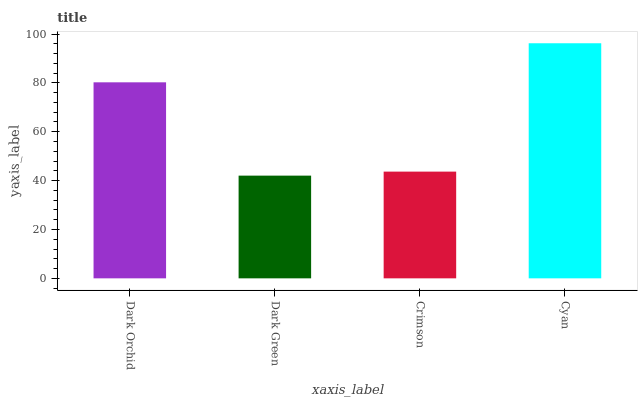Is Dark Green the minimum?
Answer yes or no. Yes. Is Cyan the maximum?
Answer yes or no. Yes. Is Crimson the minimum?
Answer yes or no. No. Is Crimson the maximum?
Answer yes or no. No. Is Crimson greater than Dark Green?
Answer yes or no. Yes. Is Dark Green less than Crimson?
Answer yes or no. Yes. Is Dark Green greater than Crimson?
Answer yes or no. No. Is Crimson less than Dark Green?
Answer yes or no. No. Is Dark Orchid the high median?
Answer yes or no. Yes. Is Crimson the low median?
Answer yes or no. Yes. Is Crimson the high median?
Answer yes or no. No. Is Dark Green the low median?
Answer yes or no. No. 